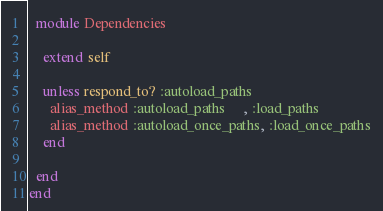<code> <loc_0><loc_0><loc_500><loc_500><_Ruby_>  module Dependencies

    extend self

    unless respond_to? :autoload_paths
      alias_method :autoload_paths     , :load_paths
      alias_method :autoload_once_paths, :load_once_paths
    end

  end
end</code> 